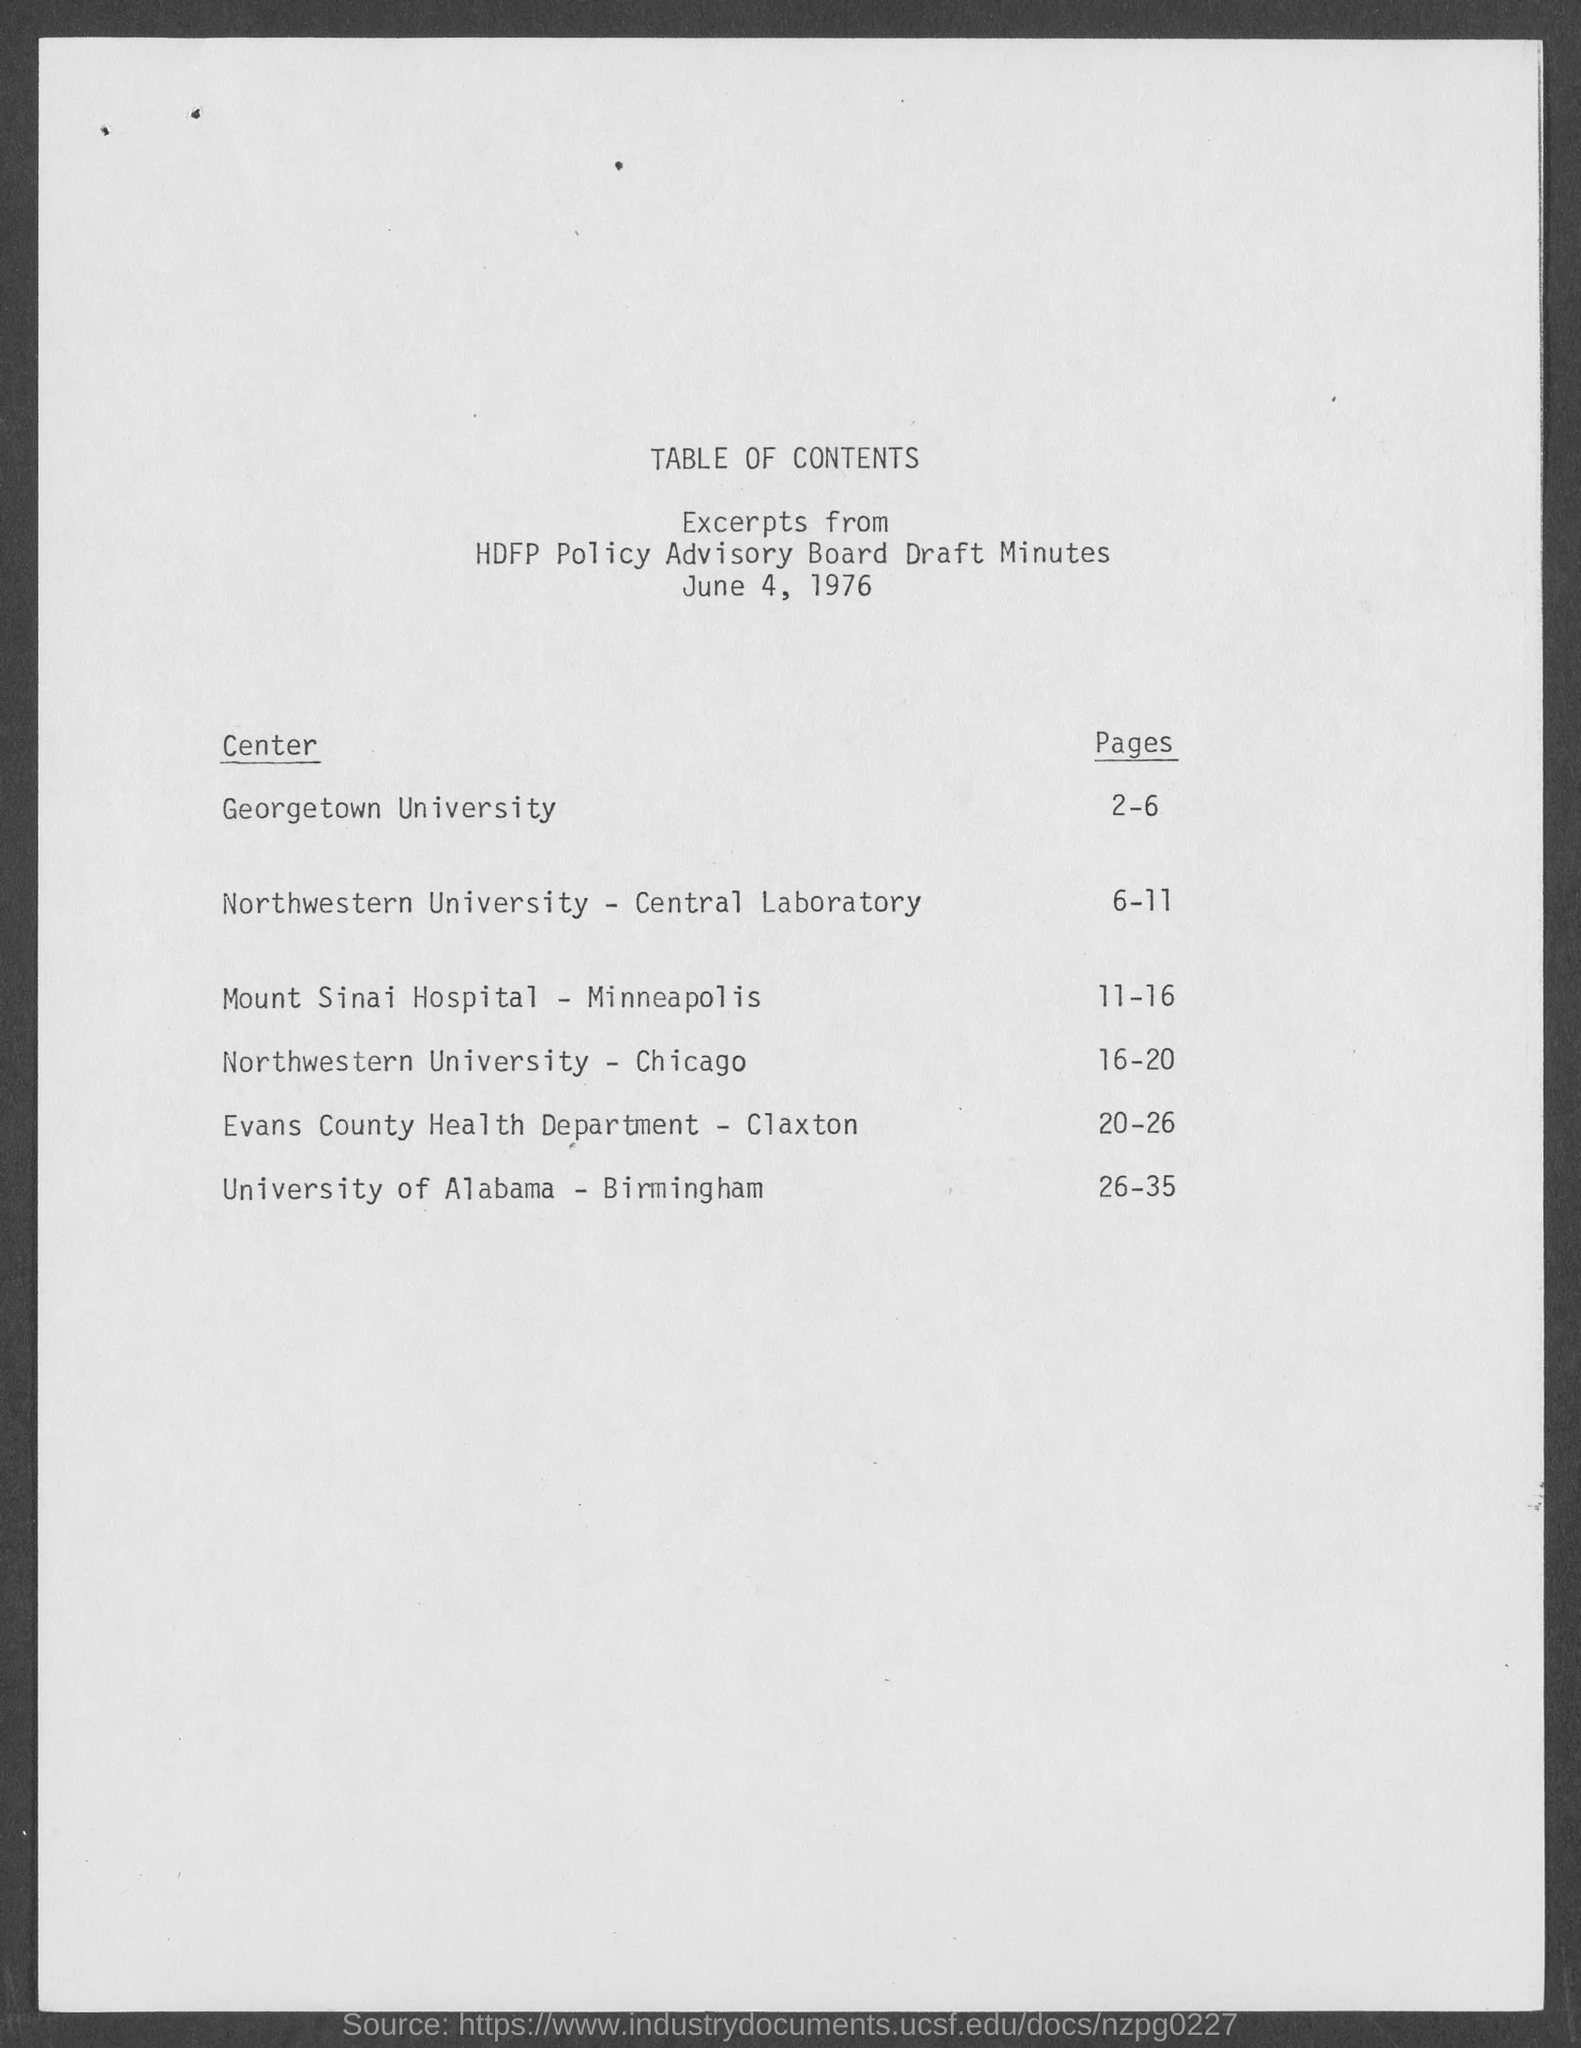Outline some significant characteristics in this image. June 4, 1976, is the date mentioned in this document. 